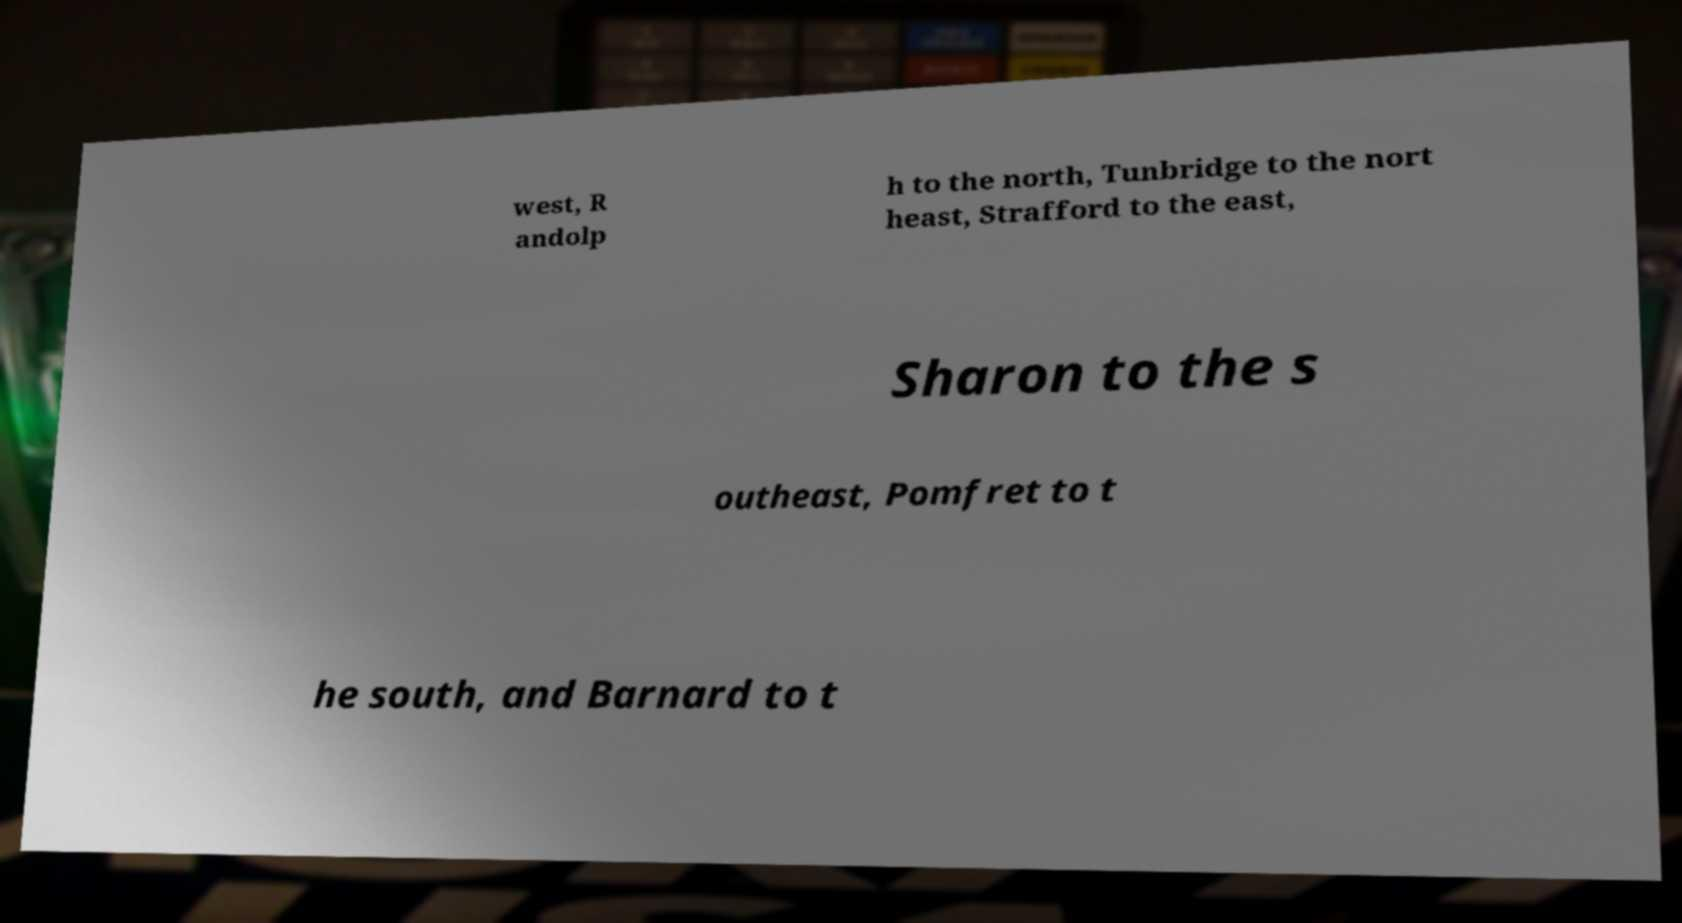What messages or text are displayed in this image? I need them in a readable, typed format. west, R andolp h to the north, Tunbridge to the nort heast, Strafford to the east, Sharon to the s outheast, Pomfret to t he south, and Barnard to t 